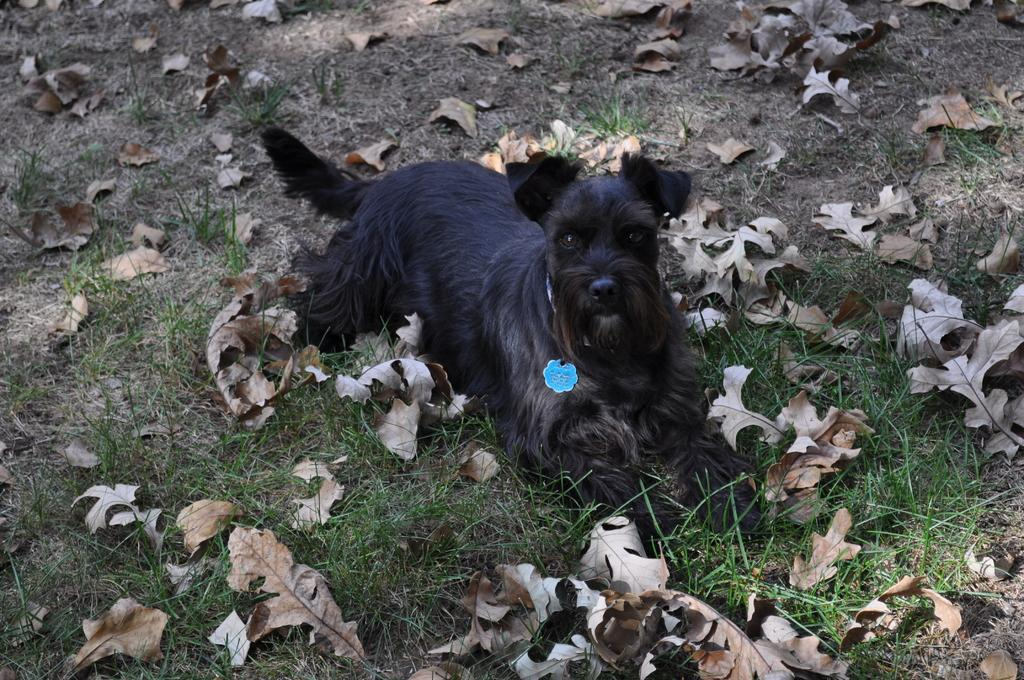What type of animal can be seen in the image? There is a dog in the image. What type of vegetation is present in the image? There is grass in the image. What additional natural elements can be seen in the image? Dry leaves are present in the image. What type of screw can be seen in the image? There is no screw present in the image. What time of day is depicted in the image? The time of day cannot be determined from the image, as there are no specific clues or indicators present. 